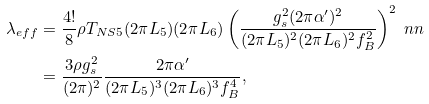Convert formula to latex. <formula><loc_0><loc_0><loc_500><loc_500>\lambda _ { e f f } & = \frac { 4 ! } { 8 } \rho T _ { N S 5 } ( 2 \pi L _ { 5 } ) ( 2 \pi L _ { 6 } ) \left ( \frac { g _ { s } ^ { 2 } ( 2 \pi \alpha ^ { \prime } ) ^ { 2 } } { ( 2 \pi L _ { 5 } ) ^ { 2 } ( 2 \pi L _ { 6 } ) ^ { 2 } f _ { B } ^ { 2 } } \right ) ^ { 2 } \ n n \\ & = \frac { 3 \rho g _ { s } ^ { 2 } } { ( 2 \pi ) ^ { 2 } } \frac { 2 \pi \alpha ^ { \prime } } { ( 2 \pi L _ { 5 } ) ^ { 3 } ( 2 \pi L _ { 6 } ) ^ { 3 } f _ { B } ^ { 4 } } ,</formula> 